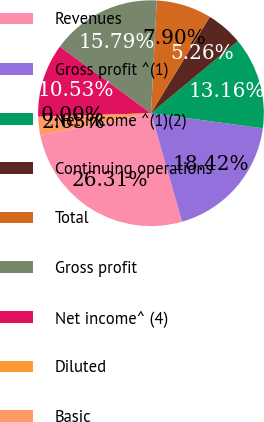Convert chart to OTSL. <chart><loc_0><loc_0><loc_500><loc_500><pie_chart><fcel>Revenues<fcel>Gross profit ^(1)<fcel>Net income ^(1)(2)<fcel>Continuing operations<fcel>Total<fcel>Gross profit<fcel>Net income^ (4)<fcel>Diluted<fcel>Basic<nl><fcel>26.31%<fcel>18.42%<fcel>13.16%<fcel>5.26%<fcel>7.9%<fcel>15.79%<fcel>10.53%<fcel>0.0%<fcel>2.63%<nl></chart> 